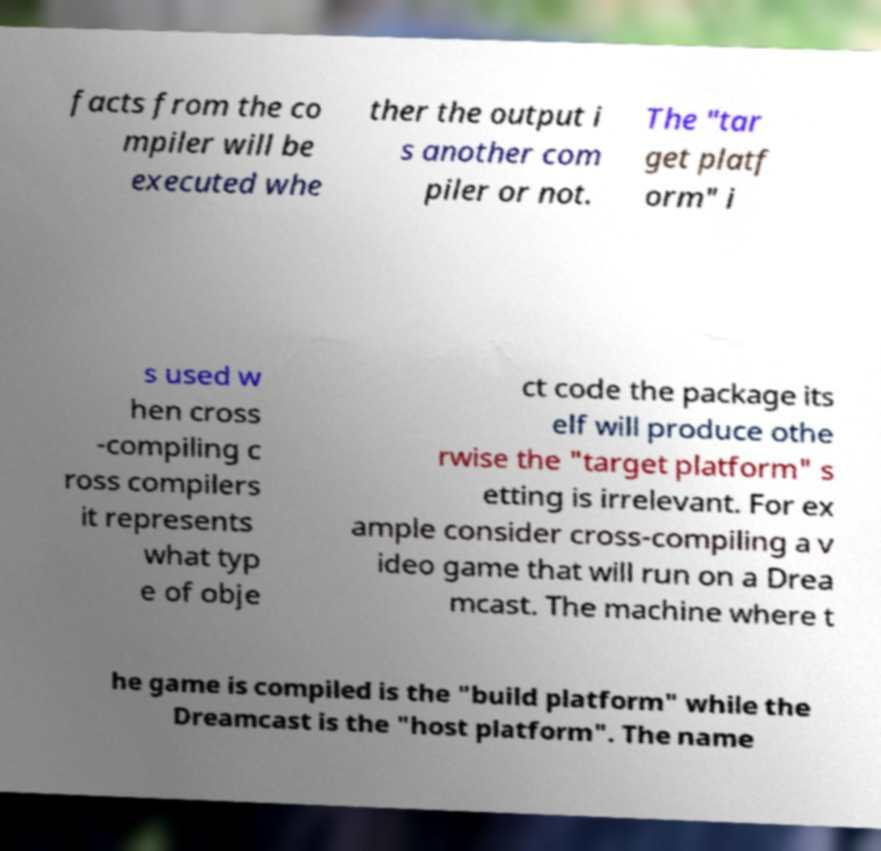Can you accurately transcribe the text from the provided image for me? facts from the co mpiler will be executed whe ther the output i s another com piler or not. The "tar get platf orm" i s used w hen cross -compiling c ross compilers it represents what typ e of obje ct code the package its elf will produce othe rwise the "target platform" s etting is irrelevant. For ex ample consider cross-compiling a v ideo game that will run on a Drea mcast. The machine where t he game is compiled is the "build platform" while the Dreamcast is the "host platform". The name 